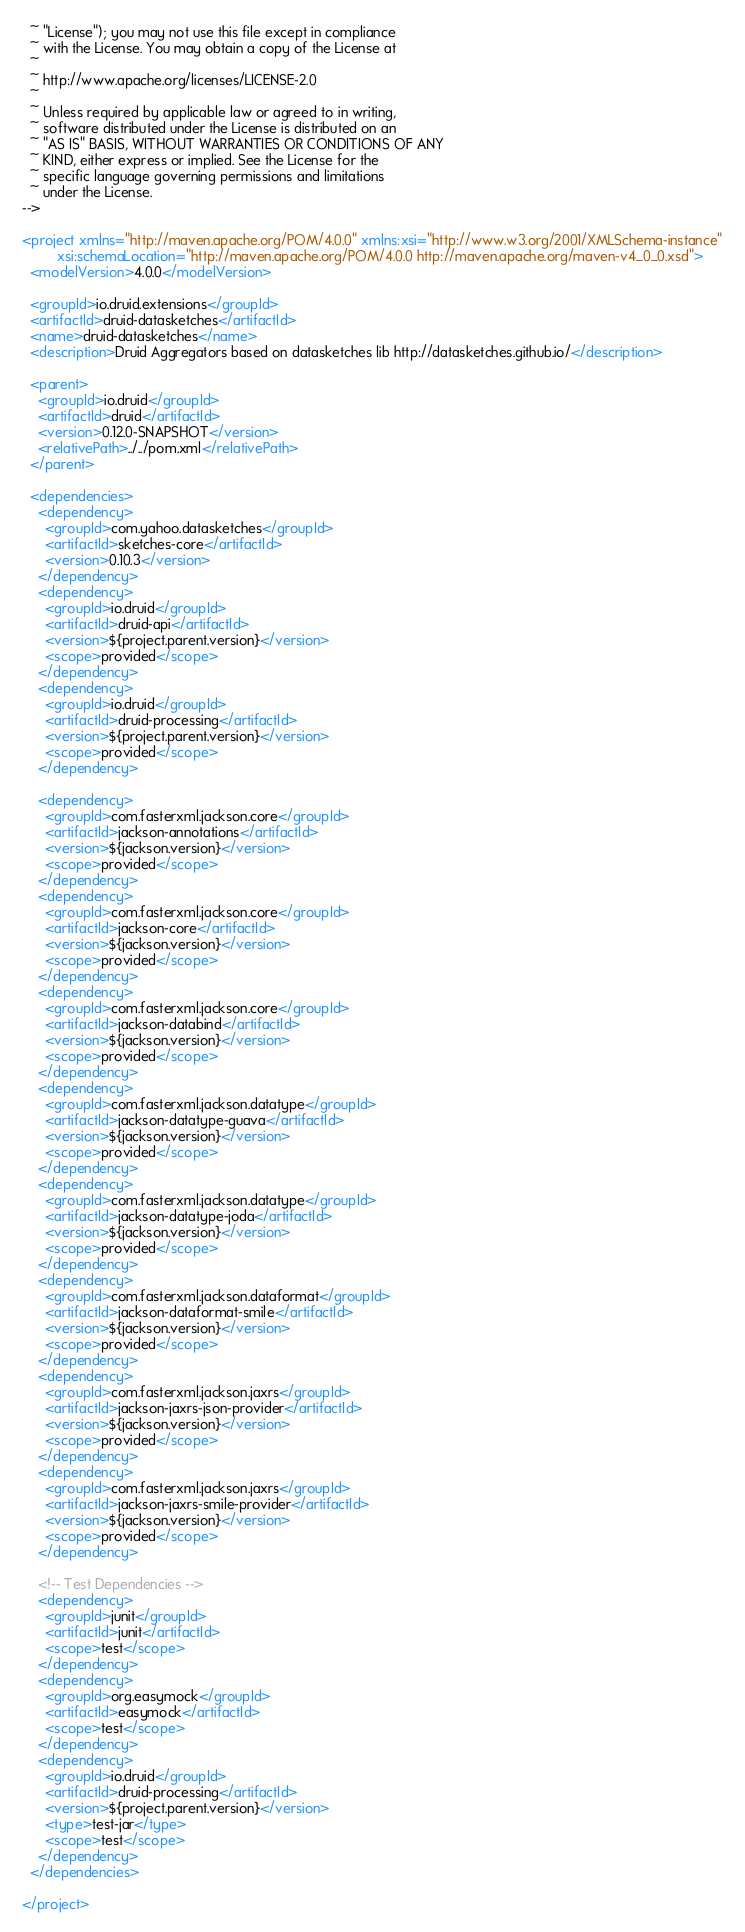<code> <loc_0><loc_0><loc_500><loc_500><_XML_>  ~ "License"); you may not use this file except in compliance
  ~ with the License. You may obtain a copy of the License at
  ~
  ~ http://www.apache.org/licenses/LICENSE-2.0
  ~
  ~ Unless required by applicable law or agreed to in writing,
  ~ software distributed under the License is distributed on an
  ~ "AS IS" BASIS, WITHOUT WARRANTIES OR CONDITIONS OF ANY
  ~ KIND, either express or implied. See the License for the
  ~ specific language governing permissions and limitations
  ~ under the License.
-->

<project xmlns="http://maven.apache.org/POM/4.0.0" xmlns:xsi="http://www.w3.org/2001/XMLSchema-instance"
         xsi:schemaLocation="http://maven.apache.org/POM/4.0.0 http://maven.apache.org/maven-v4_0_0.xsd">
  <modelVersion>4.0.0</modelVersion>

  <groupId>io.druid.extensions</groupId>
  <artifactId>druid-datasketches</artifactId>
  <name>druid-datasketches</name>
  <description>Druid Aggregators based on datasketches lib http://datasketches.github.io/</description>

  <parent>
    <groupId>io.druid</groupId>
    <artifactId>druid</artifactId>
    <version>0.12.0-SNAPSHOT</version>
    <relativePath>../../pom.xml</relativePath>
  </parent>

  <dependencies>
    <dependency>
      <groupId>com.yahoo.datasketches</groupId>
      <artifactId>sketches-core</artifactId>
      <version>0.10.3</version>
    </dependency>
    <dependency>
      <groupId>io.druid</groupId>
      <artifactId>druid-api</artifactId>
      <version>${project.parent.version}</version>
      <scope>provided</scope>
    </dependency>
    <dependency>
      <groupId>io.druid</groupId>
      <artifactId>druid-processing</artifactId>
      <version>${project.parent.version}</version>
      <scope>provided</scope>
    </dependency>

    <dependency>
      <groupId>com.fasterxml.jackson.core</groupId>
      <artifactId>jackson-annotations</artifactId>
      <version>${jackson.version}</version>
      <scope>provided</scope>
    </dependency>
    <dependency>
      <groupId>com.fasterxml.jackson.core</groupId>
      <artifactId>jackson-core</artifactId>
      <version>${jackson.version}</version>
      <scope>provided</scope>
    </dependency>
    <dependency>
      <groupId>com.fasterxml.jackson.core</groupId>
      <artifactId>jackson-databind</artifactId>
      <version>${jackson.version}</version>
      <scope>provided</scope>
    </dependency>
    <dependency>
      <groupId>com.fasterxml.jackson.datatype</groupId>
      <artifactId>jackson-datatype-guava</artifactId>
      <version>${jackson.version}</version>
      <scope>provided</scope>
    </dependency>
    <dependency>
      <groupId>com.fasterxml.jackson.datatype</groupId>
      <artifactId>jackson-datatype-joda</artifactId>
      <version>${jackson.version}</version>
      <scope>provided</scope>
    </dependency>
    <dependency>
      <groupId>com.fasterxml.jackson.dataformat</groupId>
      <artifactId>jackson-dataformat-smile</artifactId>
      <version>${jackson.version}</version>
      <scope>provided</scope>
    </dependency>
    <dependency>
      <groupId>com.fasterxml.jackson.jaxrs</groupId>
      <artifactId>jackson-jaxrs-json-provider</artifactId>
      <version>${jackson.version}</version>
      <scope>provided</scope>
    </dependency>
    <dependency>
      <groupId>com.fasterxml.jackson.jaxrs</groupId>
      <artifactId>jackson-jaxrs-smile-provider</artifactId>
      <version>${jackson.version}</version>
      <scope>provided</scope>
    </dependency>

    <!-- Test Dependencies -->
    <dependency>
      <groupId>junit</groupId>
      <artifactId>junit</artifactId>
      <scope>test</scope>
    </dependency>
    <dependency>
      <groupId>org.easymock</groupId>
      <artifactId>easymock</artifactId>
      <scope>test</scope>
    </dependency>
    <dependency>
      <groupId>io.druid</groupId>
      <artifactId>druid-processing</artifactId>
      <version>${project.parent.version}</version>
      <type>test-jar</type>
      <scope>test</scope>
    </dependency>
  </dependencies>

</project>
</code> 